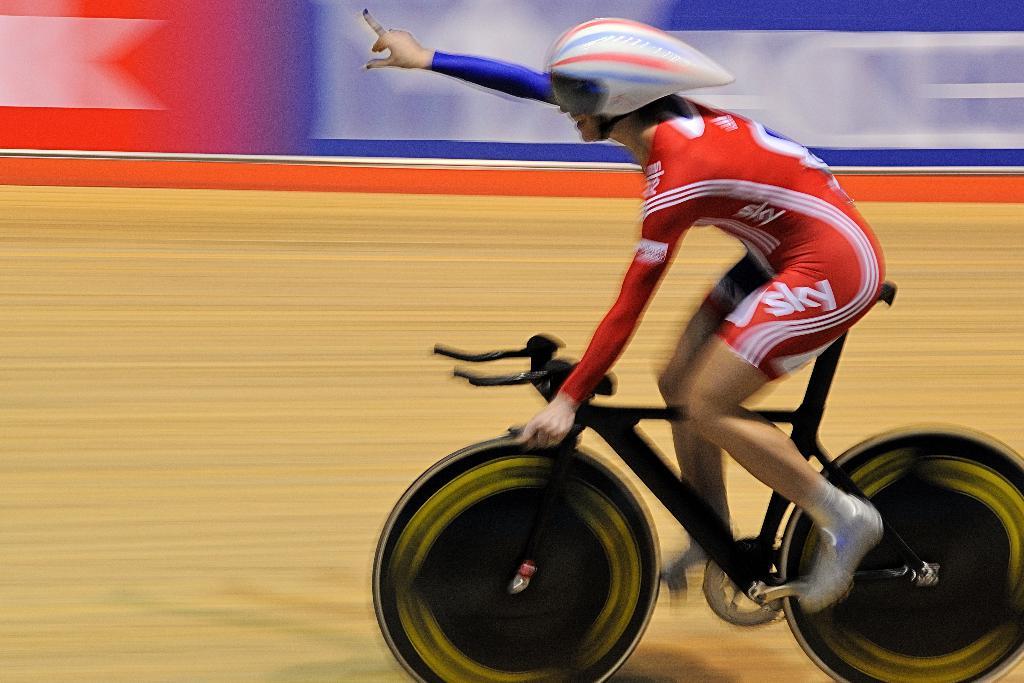Who is a sponsor on this cyclist's outfit?
Keep it short and to the point. Sky. Who is sponsoring the cyclist?
Offer a very short reply. Sky. 